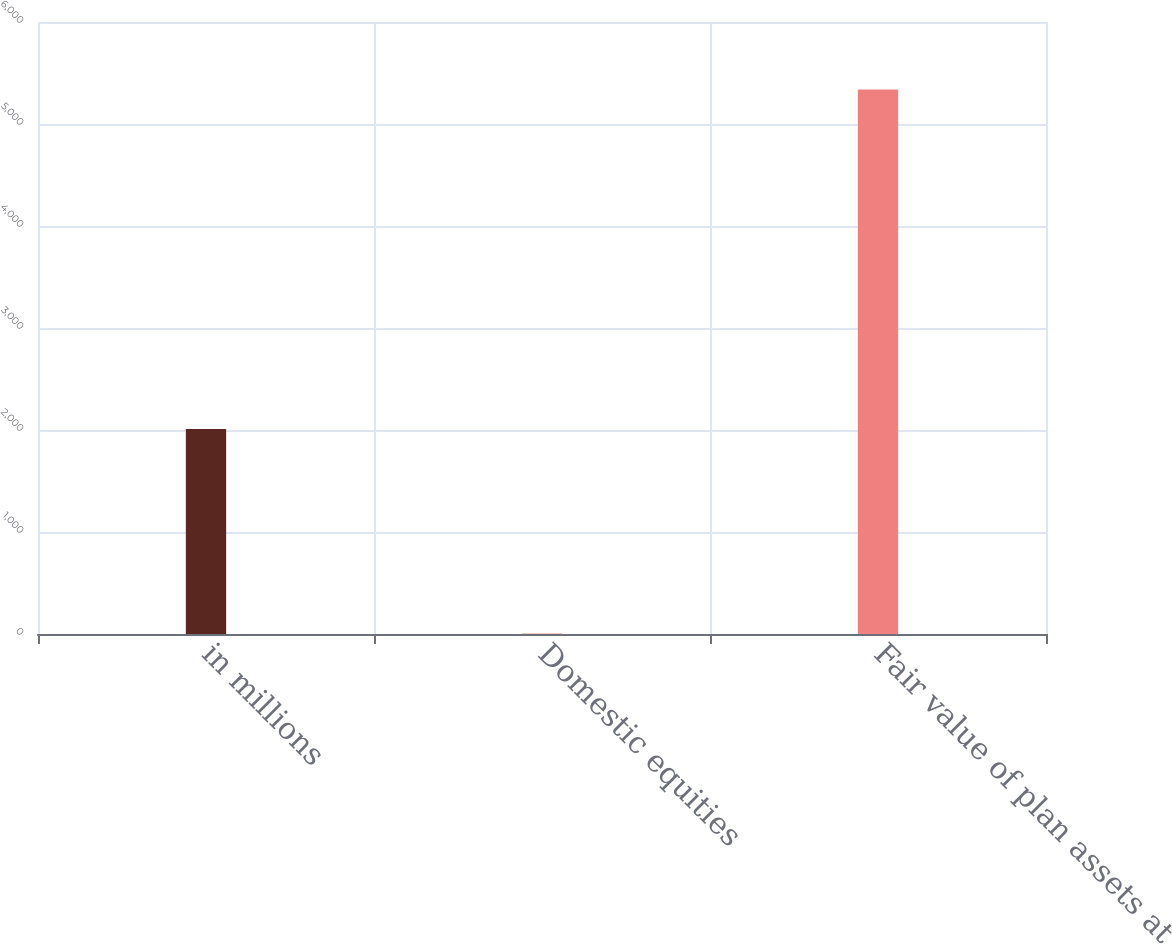Convert chart. <chart><loc_0><loc_0><loc_500><loc_500><bar_chart><fcel>in millions<fcel>Domestic equities<fcel>Fair value of plan assets at<nl><fcel>2011<fcel>2<fcel>5338<nl></chart> 